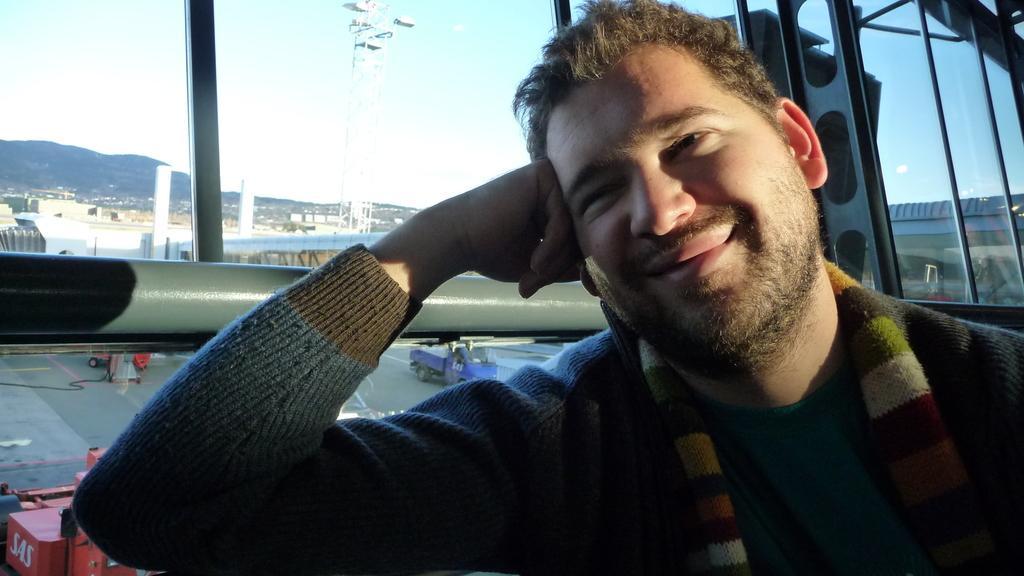How would you summarize this image in a sentence or two? In this image we can see a person. In the background of the image there are some iron objects, vehicles, towers, buildings, mountains and other objects. At the top of the image there is the sky. 